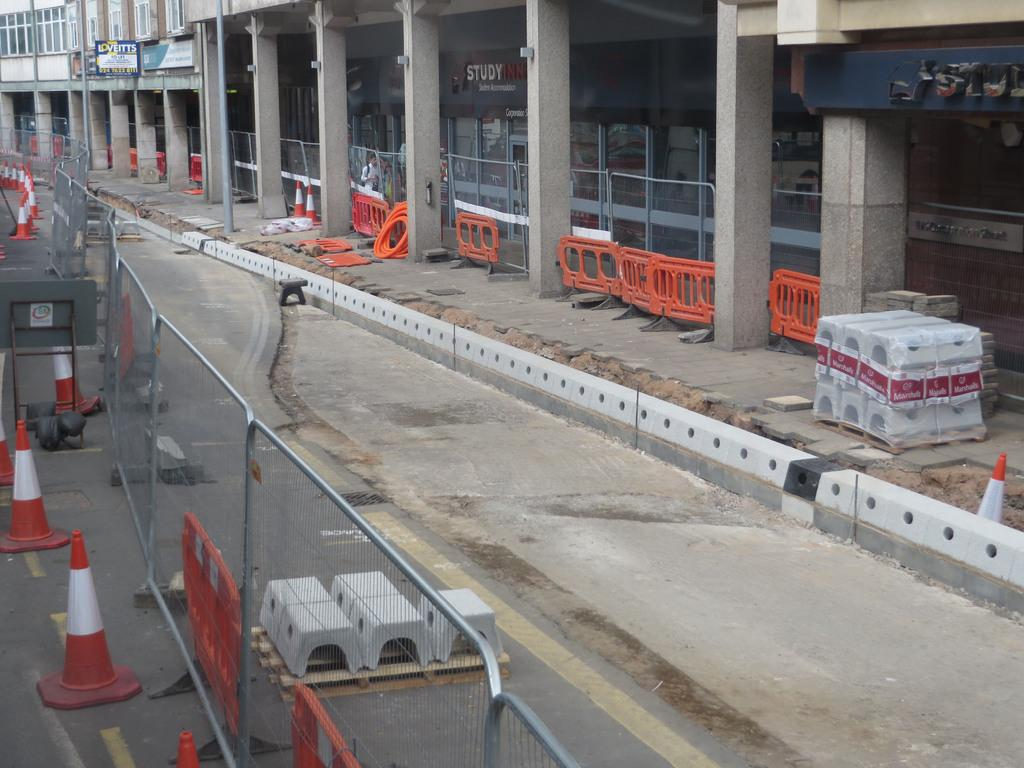What structures can be seen on the right side of the image? There are pillars, windows, doors, and buildings on the right side of the image. What type of architectural elements are present on the right side of the image? The architectural elements include pillars, windows, and doors. What is located on the left side of the image? There is fencing on the left side of the image, and traffic cones can be seen on the road. What type of pain is being expressed in the verse on the left side of the image? There is no verse present in the image, so it is not possible to answer a question about the type of pain being expressed in it. 